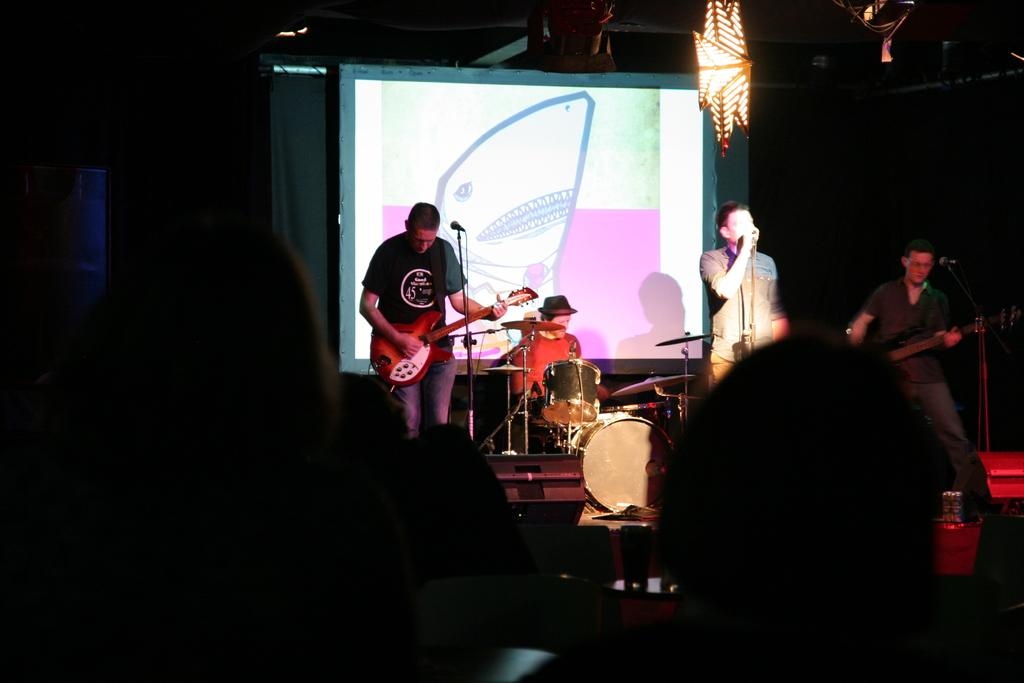What are the people in the image doing? The people in the image are playing musical instruments. Can you describe the position of the human heads in the image? Human heads are visible at the bottom of the image. What is located at the back of the image? There is a screen at the back of the image. What can be seen at the top of the image? There is light at the top of the image. What type of knee injury is visible on the person playing the guitar in the image? There is no knee injury visible in the image, as the focus is on the people playing musical instruments and not on any injuries. 